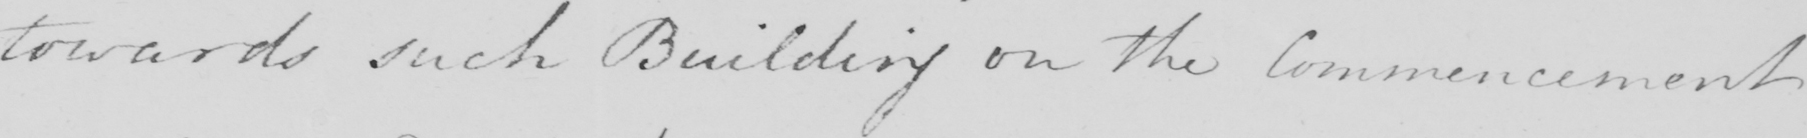Please provide the text content of this handwritten line. towards such Building on the Commencement 